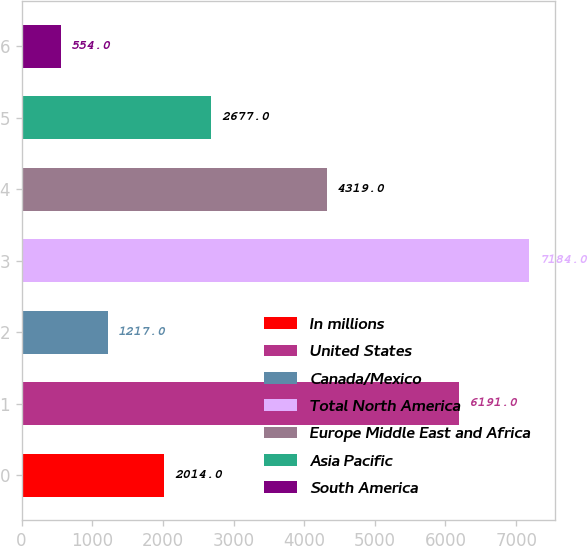Convert chart to OTSL. <chart><loc_0><loc_0><loc_500><loc_500><bar_chart><fcel>In millions<fcel>United States<fcel>Canada/Mexico<fcel>Total North America<fcel>Europe Middle East and Africa<fcel>Asia Pacific<fcel>South America<nl><fcel>2014<fcel>6191<fcel>1217<fcel>7184<fcel>4319<fcel>2677<fcel>554<nl></chart> 